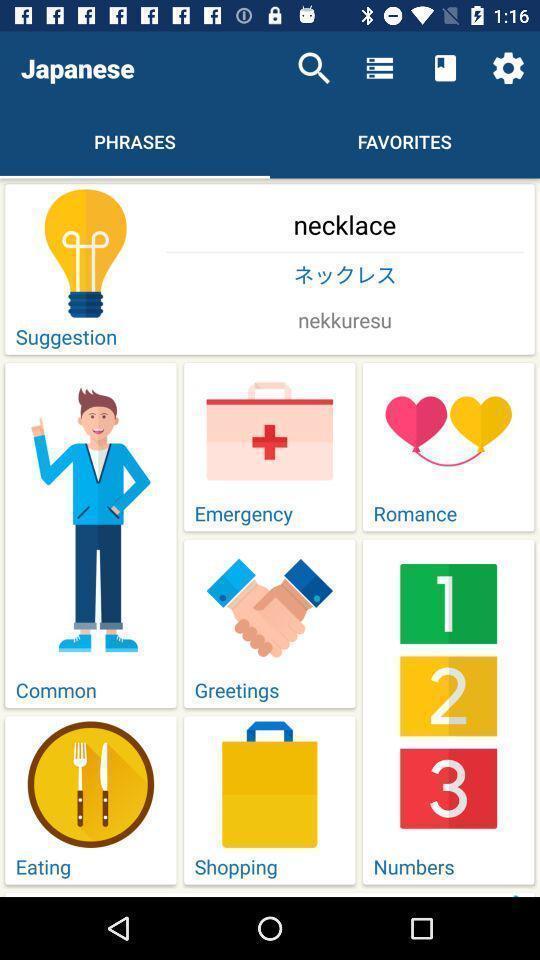Give me a summary of this screen capture. Page showing information about phrases. 